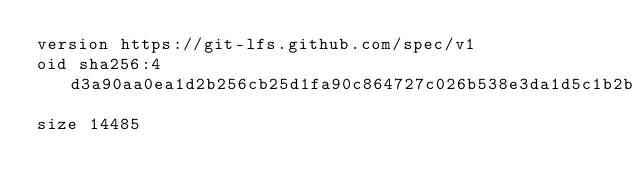<code> <loc_0><loc_0><loc_500><loc_500><_SQL_>version https://git-lfs.github.com/spec/v1
oid sha256:4d3a90aa0ea1d2b256cb25d1fa90c864727c026b538e3da1d5c1b2bdd4c89933
size 14485
</code> 